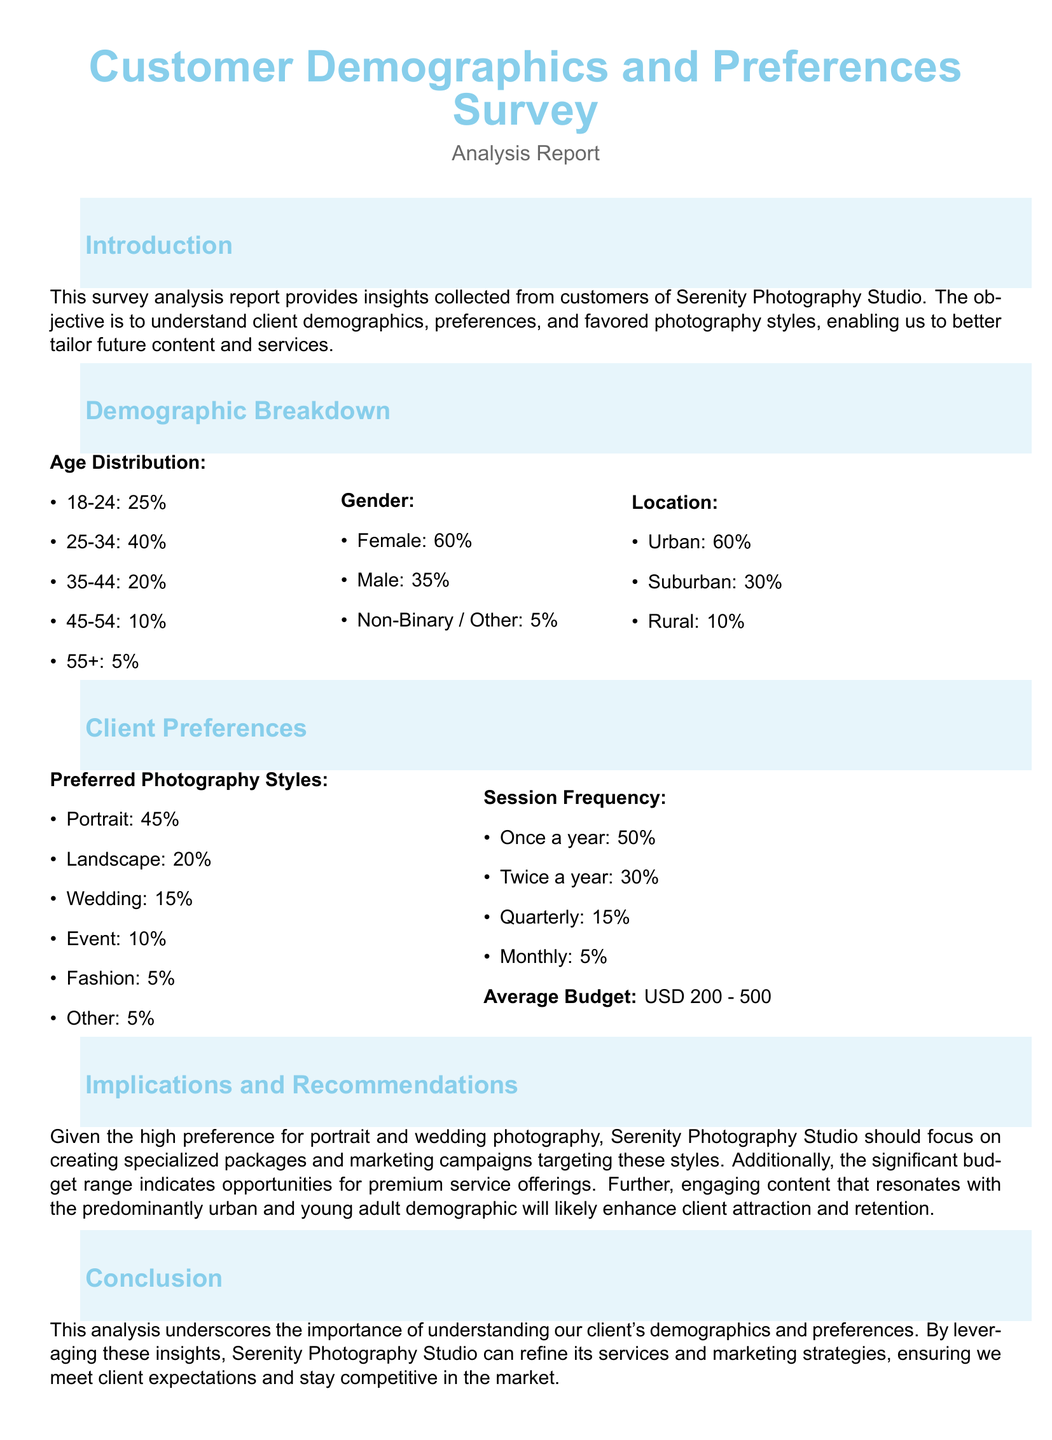What is the percentage of clients aged 18-24? The document states that 25% of clients fall within the age group of 18-24.
Answer: 25% What is the preferred photography style with the highest percentage? The report indicates that portrait photography is the most preferred style at 45%.
Answer: Portrait What is the gender distribution percentage for female clients? According to the demographic breakdown, female clients make up 60% of the total responses.
Answer: 60% What is the average budget range reported by clients? The analysis mentions that the average budget is between USD 200 and 500.
Answer: USD 200 - 500 What percentage of clients prefer to have photography sessions once a year? The survey results indicate that 50% of clients prefer sessions once a year.
Answer: 50% How many clients prefer landscape photography? The document shows that 20% of clients opted for landscape photography as their preferred style.
Answer: 20% What demographic category has the least representation in the survey? The demographic category with the least representation is clients aged 55 and over, at 5%.
Answer: 5% Which location has the highest representation among clients? The report highlights urban clients as the largest demographic group at 60%.
Answer: Urban Which two photography styles should Serenity Photography Studio focus on? The analysis recommends targeting portrait and wedding photography styles based on client preferences.
Answer: Portrait and Wedding 